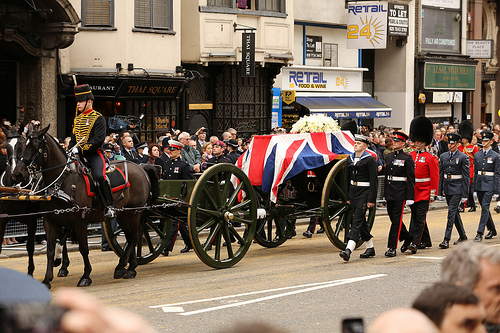Who is on the horse? A man is riding the horse. 